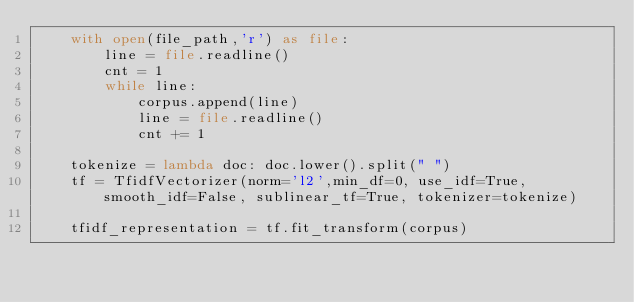Convert code to text. <code><loc_0><loc_0><loc_500><loc_500><_Python_>    with open(file_path,'r') as file:
        line = file.readline()
        cnt = 1
        while line:
            corpus.append(line)
            line = file.readline()
            cnt += 1

    tokenize = lambda doc: doc.lower().split(" ")
    tf = TfidfVectorizer(norm='l2',min_df=0, use_idf=True, smooth_idf=False, sublinear_tf=True, tokenizer=tokenize)

    tfidf_representation = tf.fit_transform(corpus)
</code> 